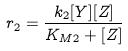<formula> <loc_0><loc_0><loc_500><loc_500>r _ { 2 } = \frac { k _ { 2 } [ Y ] [ Z ] } { K _ { M 2 } + [ Z ] }</formula> 